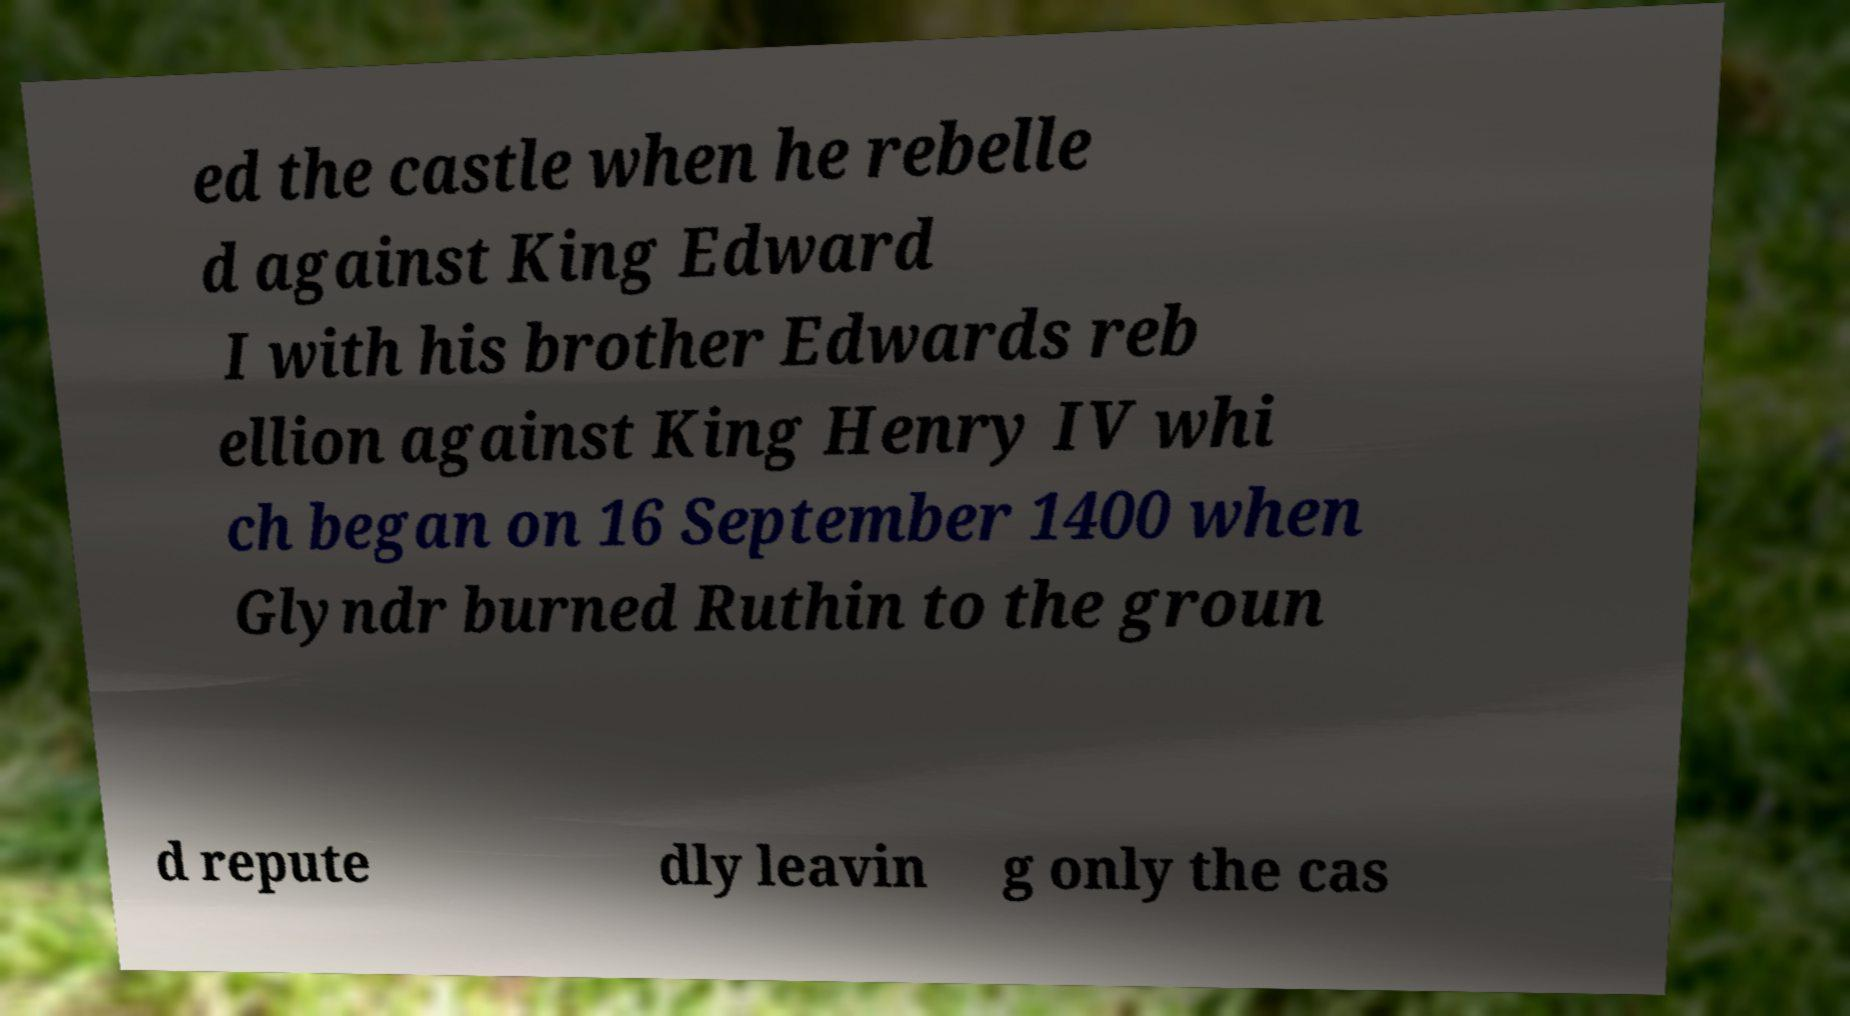There's text embedded in this image that I need extracted. Can you transcribe it verbatim? ed the castle when he rebelle d against King Edward I with his brother Edwards reb ellion against King Henry IV whi ch began on 16 September 1400 when Glyndr burned Ruthin to the groun d repute dly leavin g only the cas 